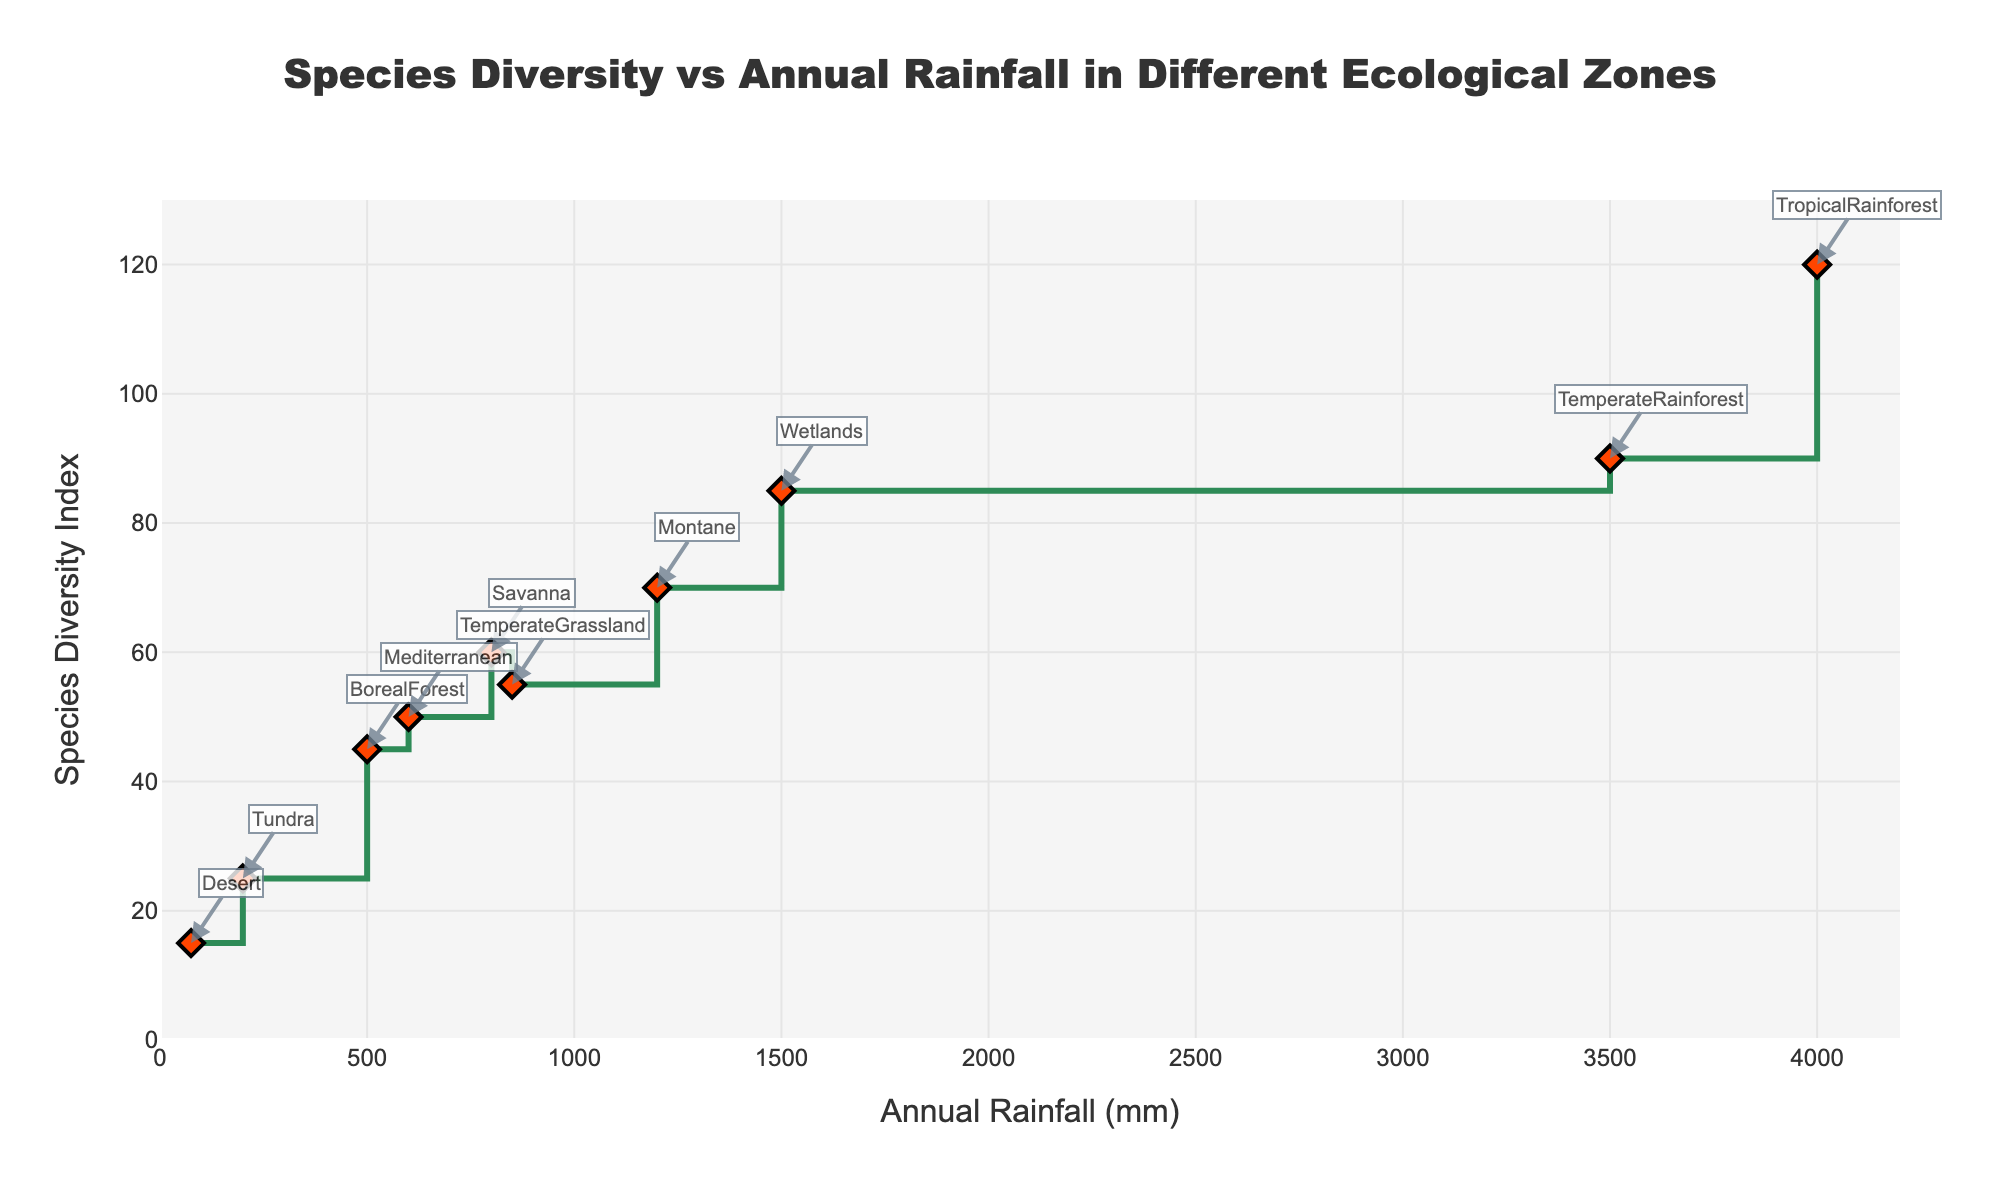What is the title of the plot? The title of the plot is located at the top and is visually distinct. It reads 'Species Diversity vs Annual Rainfall in Different Ecological Zones'.
Answer: Species Diversity vs Annual Rainfall in Different Ecological Zones How many ecological zones are featured in the plot? By counting the number of unique markers in the plot, which each represent an ecological zone, we can determine there are 10 different ecological zones.
Answer: 10 Which ecological zone has the highest annual rainfall? The data point at the farthest right on the x-axis represents the highest annual rainfall. The hovering text for this point shows 'TropicalRainforest' with a rainfall of 4000 mm.
Answer: Tropical Rainforest Which ecological zone has the lowest species diversity? The data point at the bottom of the y-axis corresponds to the lowest species diversity. The hovering text shows 'Desert' with a species diversity index of 15.
Answer: Desert What is the species diversity index for Savanna? Locate the 'Savanna' label and hover over it to see that the species diversity index for Savanna is 60.
Answer: 60 Which ecological zone has greater species diversity: Tundra or Mediterranean? Compare the vertical positions of the 'Tundra' and 'Mediterranean' labels. 'Mediterranean' is higher on the y-axis, indicating greater species diversity.
Answer: Mediterranean How much more annual rainfall does the Montane zone receive compared to the Boreal Forest? The hovering text shows Montane has 1200 mm and Boreal Forest has 500 mm of rainfall. The difference is 1200 - 500 mm = 700 mm.
Answer: 700 mm Is there an ecological zone with both lower rainfall and lower species diversity than Temperate Grassland? Locate the 'Temperate Grassland' data point and check other points. 'Desert' has both lower rainfall (75 mm < 850 mm) and lower species diversity (15 < 55).
Answer: Yes, Desert What is the average annual rainfall of the ecological zones with species diversity greater than 80? Identify zones: Temperate Rainforest (90), Tropical Rainforest (120), and Wetlands (85). Their annual rainfalls are 3500, 4000, and 1500 mm respectively. The average is (3500 + 4000 + 1500) / 3 = 3000 mm.
Answer: 3000 mm Which two ecological zones have the closest annual rainfall amounts? Compare rainfall amounts: Mediterranean (600 mm) and Boreal Forest (500 mm) are closest, with a difference of 600 - 500 mm = 100 mm.
Answer: Mediterranean and Boreal Forest 